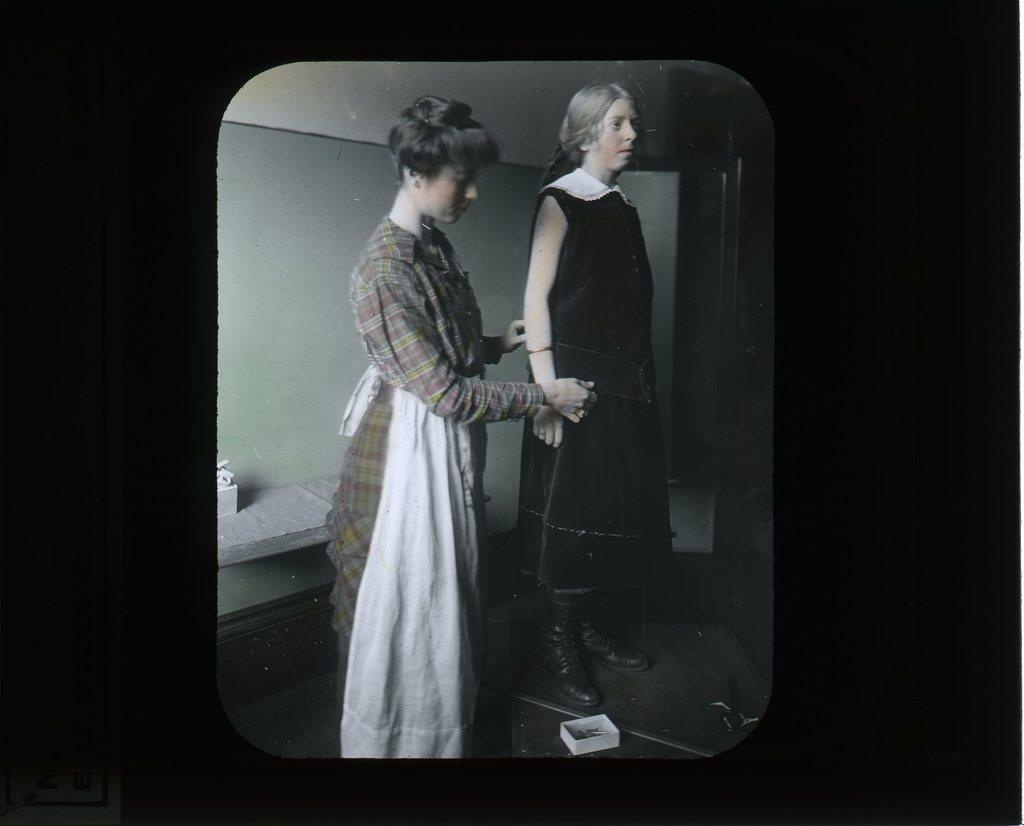How many people are in the image? There are two women in the image. What are the women doing in the image? The women are standing. What object can be seen in the image besides the women? There is a box in the image. What type of structure is visible in the image? There is a wall in the image. What type of ball is being used by the women in the image? There is no ball present in the image; the women are simply standing. 